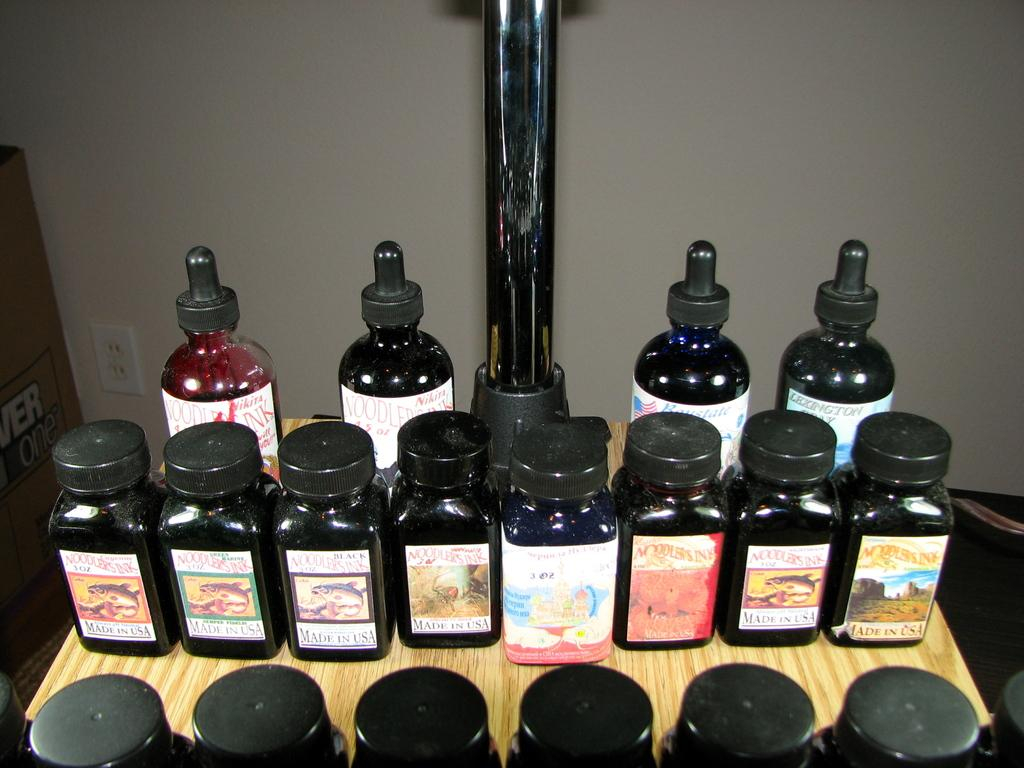What objects are on the table in the image? There are bottles on the table in the image. What is unique about the bottles? Stickers are attached to the bottles. What is located to the left of the table? There is a cardboard box and a switch board to the left of the table. What can be seen in the background of the image? There is a wall in the background of the image. What type of polish is being applied to the clocks in the image? There are no clocks or polish present in the image. 